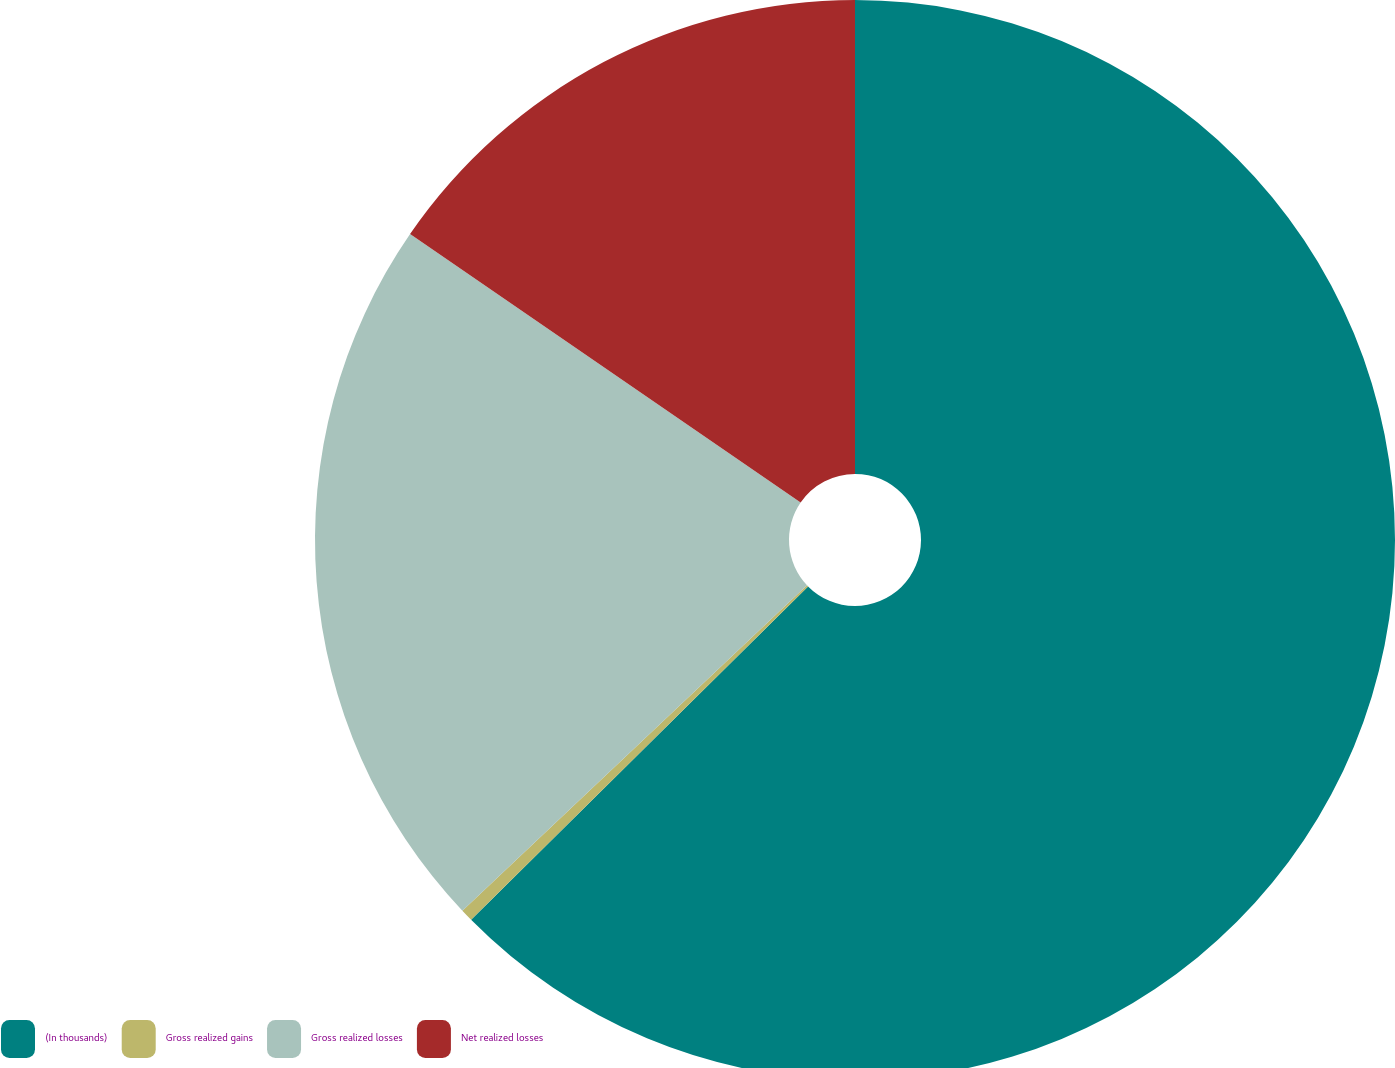<chart> <loc_0><loc_0><loc_500><loc_500><pie_chart><fcel>(In thousands)<fcel>Gross realized gains<fcel>Gross realized losses<fcel>Net realized losses<nl><fcel>62.58%<fcel>0.37%<fcel>21.63%<fcel>15.41%<nl></chart> 